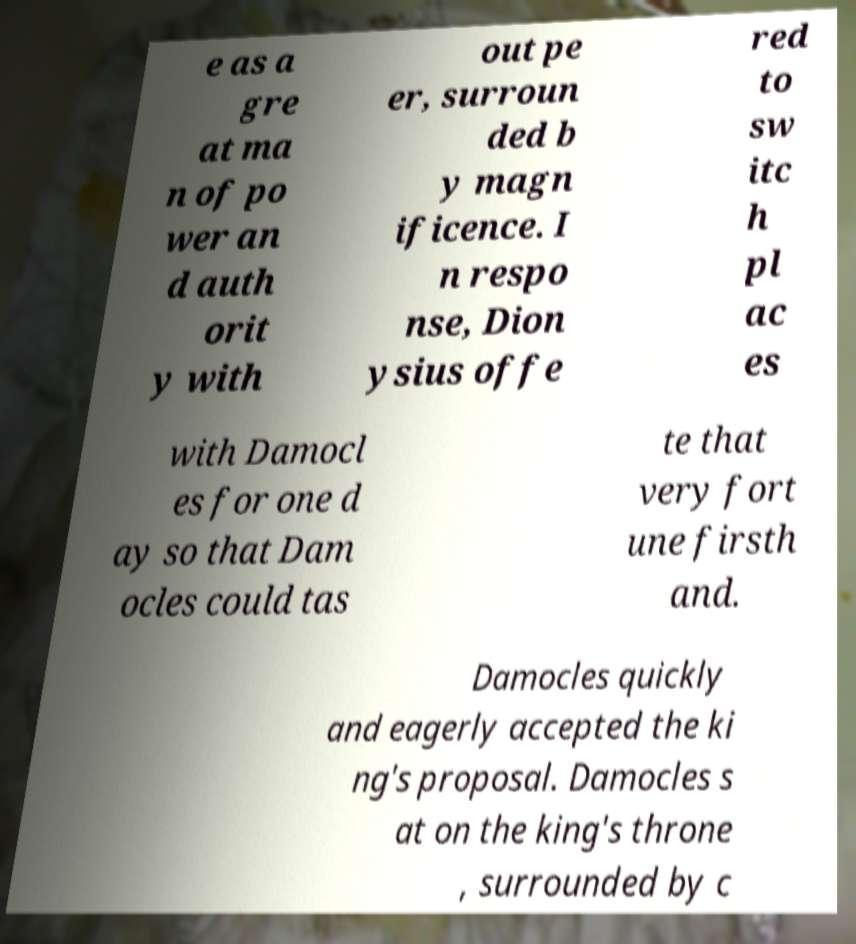Can you accurately transcribe the text from the provided image for me? e as a gre at ma n of po wer an d auth orit y with out pe er, surroun ded b y magn ificence. I n respo nse, Dion ysius offe red to sw itc h pl ac es with Damocl es for one d ay so that Dam ocles could tas te that very fort une firsth and. Damocles quickly and eagerly accepted the ki ng's proposal. Damocles s at on the king's throne , surrounded by c 